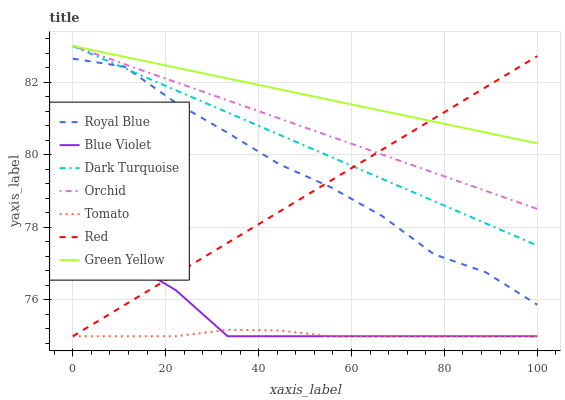Does Tomato have the minimum area under the curve?
Answer yes or no. Yes. Does Green Yellow have the maximum area under the curve?
Answer yes or no. Yes. Does Dark Turquoise have the minimum area under the curve?
Answer yes or no. No. Does Dark Turquoise have the maximum area under the curve?
Answer yes or no. No. Is Dark Turquoise the smoothest?
Answer yes or no. Yes. Is Royal Blue the roughest?
Answer yes or no. Yes. Is Royal Blue the smoothest?
Answer yes or no. No. Is Dark Turquoise the roughest?
Answer yes or no. No. Does Dark Turquoise have the lowest value?
Answer yes or no. No. Does Orchid have the highest value?
Answer yes or no. Yes. Does Royal Blue have the highest value?
Answer yes or no. No. Is Royal Blue less than Orchid?
Answer yes or no. Yes. Is Orchid greater than Royal Blue?
Answer yes or no. Yes. Does Red intersect Blue Violet?
Answer yes or no. Yes. Is Red less than Blue Violet?
Answer yes or no. No. Is Red greater than Blue Violet?
Answer yes or no. No. Does Royal Blue intersect Orchid?
Answer yes or no. No. 